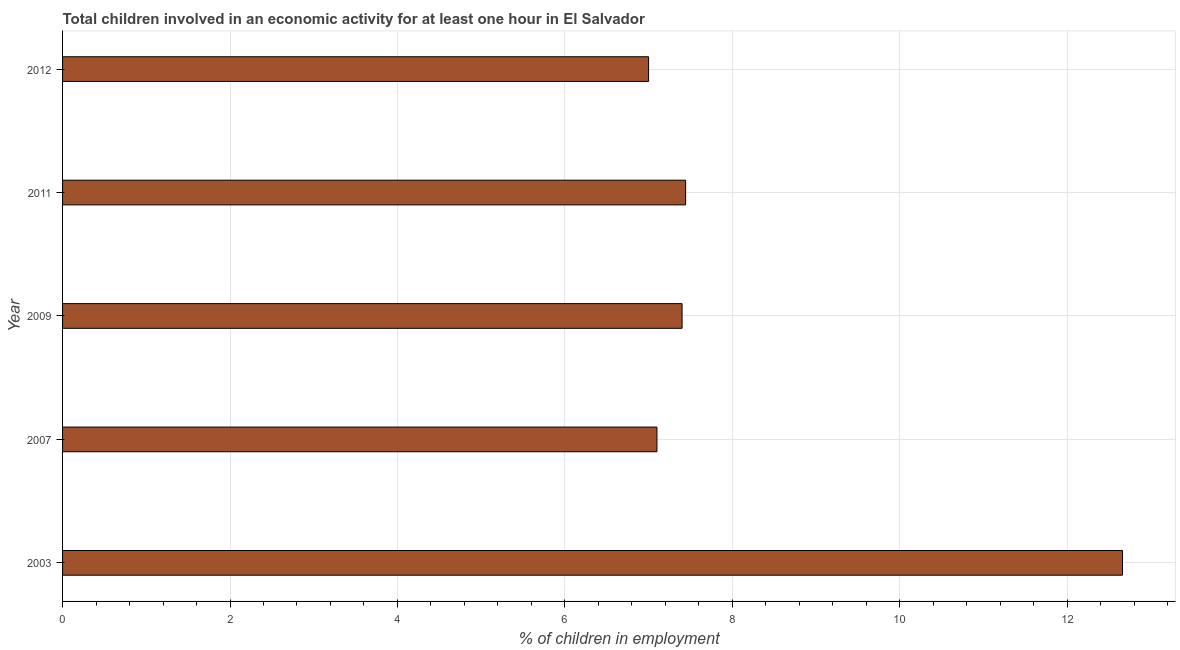Does the graph contain grids?
Provide a short and direct response. Yes. What is the title of the graph?
Your answer should be very brief. Total children involved in an economic activity for at least one hour in El Salvador. What is the label or title of the X-axis?
Keep it short and to the point. % of children in employment. What is the percentage of children in employment in 2011?
Offer a very short reply. 7.44. Across all years, what is the maximum percentage of children in employment?
Offer a very short reply. 12.66. What is the sum of the percentage of children in employment?
Ensure brevity in your answer.  41.6. What is the difference between the percentage of children in employment in 2003 and 2011?
Provide a short and direct response. 5.22. What is the average percentage of children in employment per year?
Provide a succinct answer. 8.32. In how many years, is the percentage of children in employment greater than 4.8 %?
Offer a very short reply. 5. What is the ratio of the percentage of children in employment in 2011 to that in 2012?
Give a very brief answer. 1.06. Is the difference between the percentage of children in employment in 2011 and 2012 greater than the difference between any two years?
Give a very brief answer. No. What is the difference between the highest and the second highest percentage of children in employment?
Provide a succinct answer. 5.22. Is the sum of the percentage of children in employment in 2003 and 2007 greater than the maximum percentage of children in employment across all years?
Offer a very short reply. Yes. What is the difference between the highest and the lowest percentage of children in employment?
Make the answer very short. 5.66. How many years are there in the graph?
Give a very brief answer. 5. Are the values on the major ticks of X-axis written in scientific E-notation?
Provide a short and direct response. No. What is the % of children in employment in 2003?
Make the answer very short. 12.66. What is the % of children in employment in 2009?
Ensure brevity in your answer.  7.4. What is the % of children in employment of 2011?
Make the answer very short. 7.44. What is the difference between the % of children in employment in 2003 and 2007?
Give a very brief answer. 5.56. What is the difference between the % of children in employment in 2003 and 2009?
Offer a very short reply. 5.26. What is the difference between the % of children in employment in 2003 and 2011?
Your answer should be very brief. 5.22. What is the difference between the % of children in employment in 2003 and 2012?
Your answer should be compact. 5.66. What is the difference between the % of children in employment in 2007 and 2011?
Ensure brevity in your answer.  -0.34. What is the difference between the % of children in employment in 2007 and 2012?
Ensure brevity in your answer.  0.1. What is the difference between the % of children in employment in 2009 and 2011?
Keep it short and to the point. -0.04. What is the difference between the % of children in employment in 2009 and 2012?
Make the answer very short. 0.4. What is the difference between the % of children in employment in 2011 and 2012?
Ensure brevity in your answer.  0.44. What is the ratio of the % of children in employment in 2003 to that in 2007?
Keep it short and to the point. 1.78. What is the ratio of the % of children in employment in 2003 to that in 2009?
Your answer should be compact. 1.71. What is the ratio of the % of children in employment in 2003 to that in 2011?
Offer a terse response. 1.7. What is the ratio of the % of children in employment in 2003 to that in 2012?
Provide a succinct answer. 1.81. What is the ratio of the % of children in employment in 2007 to that in 2011?
Offer a very short reply. 0.95. What is the ratio of the % of children in employment in 2007 to that in 2012?
Ensure brevity in your answer.  1.01. What is the ratio of the % of children in employment in 2009 to that in 2011?
Keep it short and to the point. 0.99. What is the ratio of the % of children in employment in 2009 to that in 2012?
Offer a terse response. 1.06. What is the ratio of the % of children in employment in 2011 to that in 2012?
Make the answer very short. 1.06. 